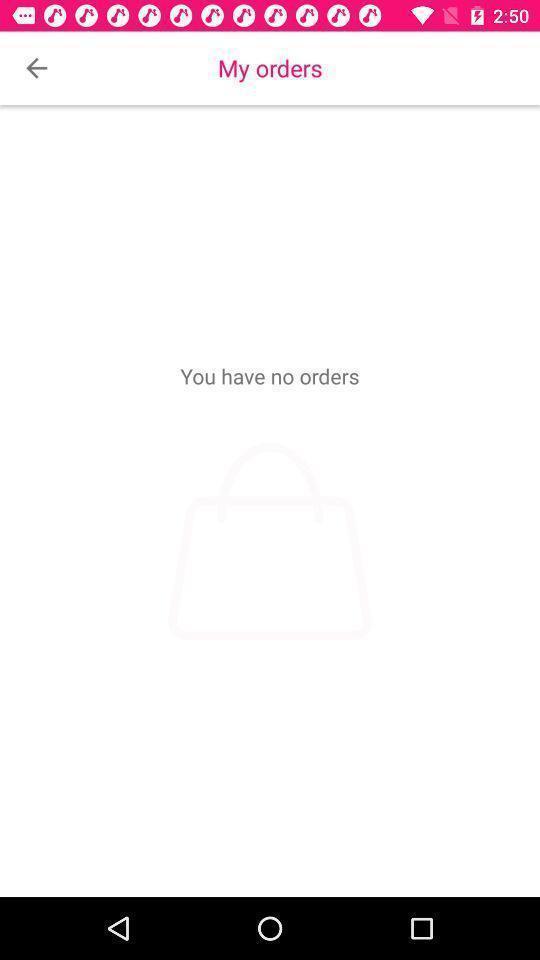Describe the visual elements of this screenshot. Page showing information about orders. 